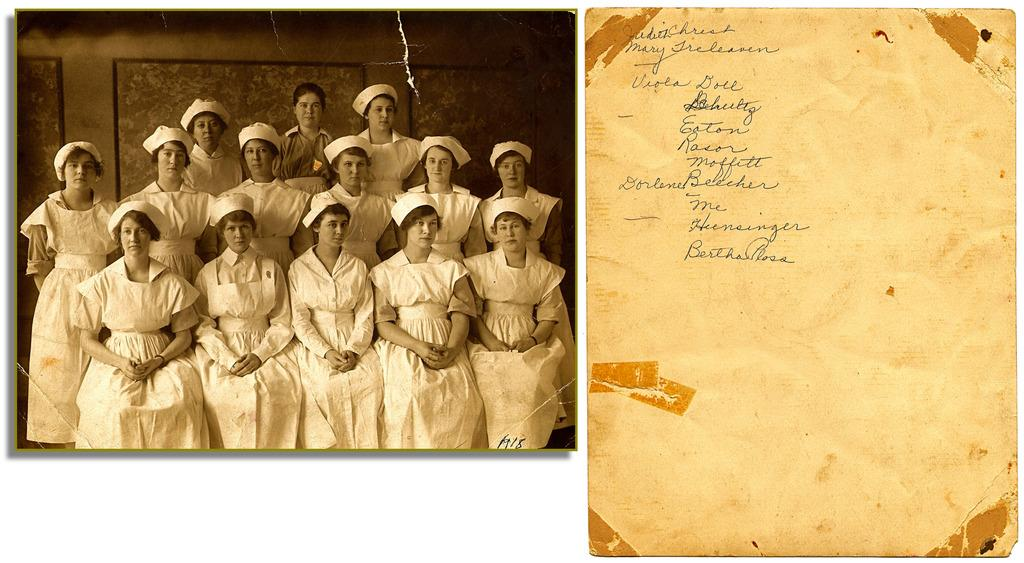What is located on the right side of the image? There is a board with text on the right side of the image. What is on the left side of the image? There is a photograph on the left side of the image. What can be seen in the photograph? The photograph contains a group of people. How many snails are crawling on the edge of the board in the image? There are no snails present in the image. What type of rail can be seen in the background of the photograph? There is no rail present in the image; it only contains a board with text and a photograph. 